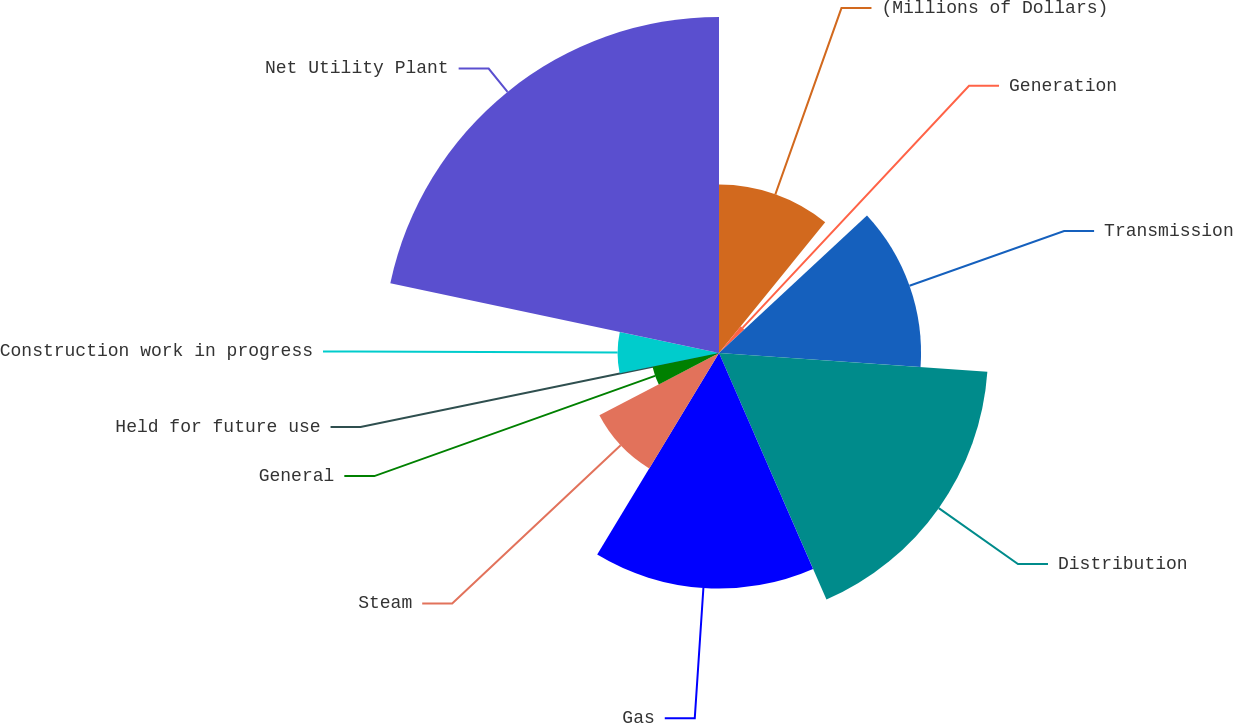Convert chart. <chart><loc_0><loc_0><loc_500><loc_500><pie_chart><fcel>(Millions of Dollars)<fcel>Generation<fcel>Transmission<fcel>Distribution<fcel>Gas<fcel>Steam<fcel>General<fcel>Held for future use<fcel>Construction work in progress<fcel>Net Utility Plant<nl><fcel>10.86%<fcel>2.22%<fcel>13.03%<fcel>17.35%<fcel>15.19%<fcel>8.7%<fcel>4.38%<fcel>0.06%<fcel>6.54%<fcel>21.67%<nl></chart> 